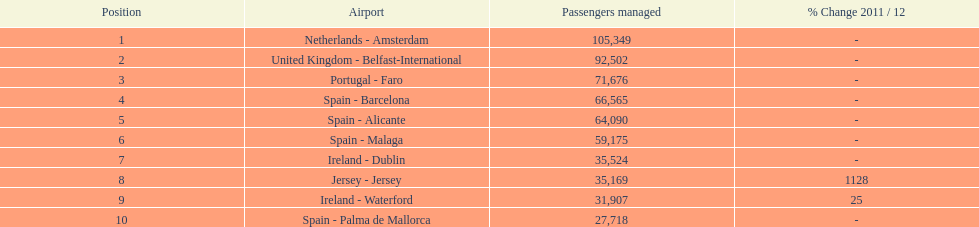Where is the most popular destination for passengers leaving london southend airport? Netherlands - Amsterdam. Help me parse the entirety of this table. {'header': ['Position', 'Airport', 'Passengers managed', '% Change 2011 / 12'], 'rows': [['1', 'Netherlands - Amsterdam', '105,349', '-'], ['2', 'United Kingdom - Belfast-International', '92,502', '-'], ['3', 'Portugal - Faro', '71,676', '-'], ['4', 'Spain - Barcelona', '66,565', '-'], ['5', 'Spain - Alicante', '64,090', '-'], ['6', 'Spain - Malaga', '59,175', '-'], ['7', 'Ireland - Dublin', '35,524', '-'], ['8', 'Jersey - Jersey', '35,169', '1128'], ['9', 'Ireland - Waterford', '31,907', '25'], ['10', 'Spain - Palma de Mallorca', '27,718', '-']]} 